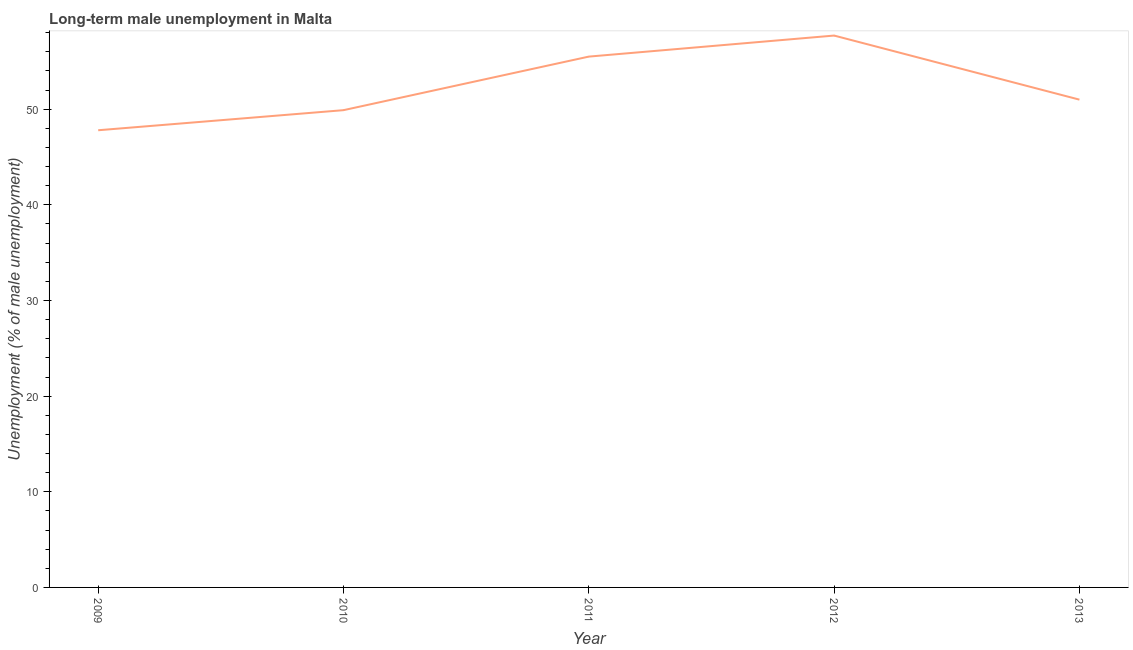Across all years, what is the maximum long-term male unemployment?
Ensure brevity in your answer.  57.7. Across all years, what is the minimum long-term male unemployment?
Offer a terse response. 47.8. In which year was the long-term male unemployment maximum?
Keep it short and to the point. 2012. What is the sum of the long-term male unemployment?
Make the answer very short. 261.9. What is the difference between the long-term male unemployment in 2009 and 2013?
Your answer should be compact. -3.2. What is the average long-term male unemployment per year?
Your answer should be compact. 52.38. What is the median long-term male unemployment?
Your response must be concise. 51. Do a majority of the years between 2013 and 2009 (inclusive) have long-term male unemployment greater than 48 %?
Your answer should be very brief. Yes. What is the ratio of the long-term male unemployment in 2012 to that in 2013?
Keep it short and to the point. 1.13. Is the difference between the long-term male unemployment in 2011 and 2012 greater than the difference between any two years?
Make the answer very short. No. What is the difference between the highest and the second highest long-term male unemployment?
Keep it short and to the point. 2.2. Is the sum of the long-term male unemployment in 2012 and 2013 greater than the maximum long-term male unemployment across all years?
Your answer should be compact. Yes. What is the difference between the highest and the lowest long-term male unemployment?
Give a very brief answer. 9.9. Does the long-term male unemployment monotonically increase over the years?
Your answer should be very brief. No. How many years are there in the graph?
Keep it short and to the point. 5. Are the values on the major ticks of Y-axis written in scientific E-notation?
Give a very brief answer. No. Does the graph contain any zero values?
Make the answer very short. No. Does the graph contain grids?
Ensure brevity in your answer.  No. What is the title of the graph?
Provide a short and direct response. Long-term male unemployment in Malta. What is the label or title of the Y-axis?
Your answer should be very brief. Unemployment (% of male unemployment). What is the Unemployment (% of male unemployment) of 2009?
Your response must be concise. 47.8. What is the Unemployment (% of male unemployment) of 2010?
Give a very brief answer. 49.9. What is the Unemployment (% of male unemployment) in 2011?
Your answer should be very brief. 55.5. What is the Unemployment (% of male unemployment) in 2012?
Your answer should be very brief. 57.7. What is the difference between the Unemployment (% of male unemployment) in 2009 and 2011?
Your response must be concise. -7.7. What is the difference between the Unemployment (% of male unemployment) in 2009 and 2013?
Provide a succinct answer. -3.2. What is the difference between the Unemployment (% of male unemployment) in 2010 and 2011?
Provide a short and direct response. -5.6. What is the difference between the Unemployment (% of male unemployment) in 2010 and 2012?
Keep it short and to the point. -7.8. What is the difference between the Unemployment (% of male unemployment) in 2011 and 2012?
Give a very brief answer. -2.2. What is the difference between the Unemployment (% of male unemployment) in 2011 and 2013?
Provide a succinct answer. 4.5. What is the ratio of the Unemployment (% of male unemployment) in 2009 to that in 2010?
Provide a succinct answer. 0.96. What is the ratio of the Unemployment (% of male unemployment) in 2009 to that in 2011?
Provide a short and direct response. 0.86. What is the ratio of the Unemployment (% of male unemployment) in 2009 to that in 2012?
Offer a very short reply. 0.83. What is the ratio of the Unemployment (% of male unemployment) in 2009 to that in 2013?
Your answer should be compact. 0.94. What is the ratio of the Unemployment (% of male unemployment) in 2010 to that in 2011?
Make the answer very short. 0.9. What is the ratio of the Unemployment (% of male unemployment) in 2010 to that in 2012?
Give a very brief answer. 0.86. What is the ratio of the Unemployment (% of male unemployment) in 2010 to that in 2013?
Provide a short and direct response. 0.98. What is the ratio of the Unemployment (% of male unemployment) in 2011 to that in 2012?
Provide a succinct answer. 0.96. What is the ratio of the Unemployment (% of male unemployment) in 2011 to that in 2013?
Keep it short and to the point. 1.09. What is the ratio of the Unemployment (% of male unemployment) in 2012 to that in 2013?
Your response must be concise. 1.13. 